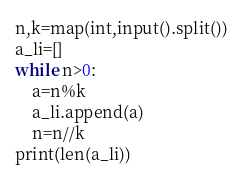<code> <loc_0><loc_0><loc_500><loc_500><_Python_>n,k=map(int,input().split())
a_li=[]
while n>0:
    a=n%k
    a_li.append(a)
    n=n//k
print(len(a_li))</code> 